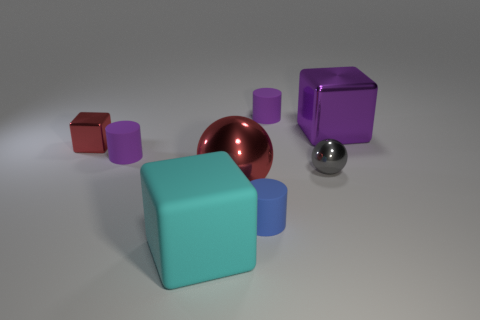Subtract all cyan blocks. How many blocks are left? 2 Subtract all small purple cylinders. How many cylinders are left? 1 Subtract all balls. How many objects are left? 6 Subtract 2 cylinders. How many cylinders are left? 1 Add 2 small purple matte balls. How many objects exist? 10 Subtract 0 green cylinders. How many objects are left? 8 Subtract all red cylinders. Subtract all yellow blocks. How many cylinders are left? 3 Subtract all gray cubes. How many gray spheres are left? 1 Subtract all rubber cylinders. Subtract all blue matte cylinders. How many objects are left? 4 Add 3 purple shiny cubes. How many purple shiny cubes are left? 4 